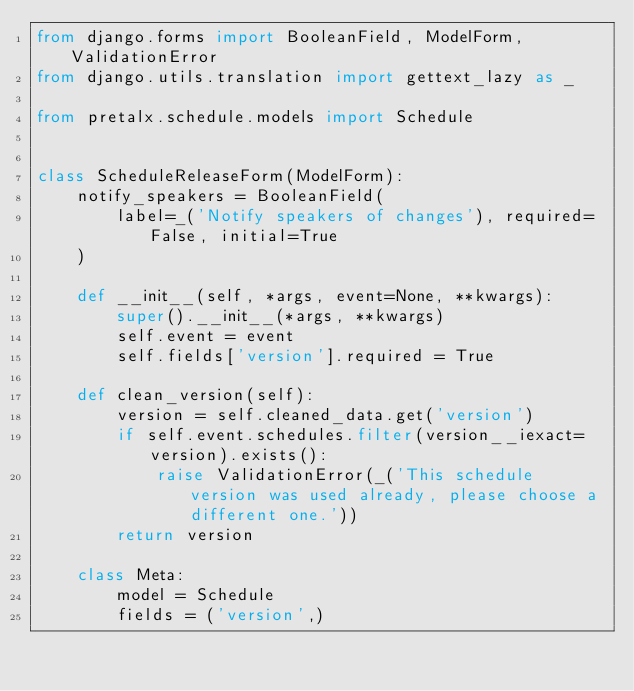<code> <loc_0><loc_0><loc_500><loc_500><_Python_>from django.forms import BooleanField, ModelForm, ValidationError
from django.utils.translation import gettext_lazy as _

from pretalx.schedule.models import Schedule


class ScheduleReleaseForm(ModelForm):
    notify_speakers = BooleanField(
        label=_('Notify speakers of changes'), required=False, initial=True
    )

    def __init__(self, *args, event=None, **kwargs):
        super().__init__(*args, **kwargs)
        self.event = event
        self.fields['version'].required = True

    def clean_version(self):
        version = self.cleaned_data.get('version')
        if self.event.schedules.filter(version__iexact=version).exists():
            raise ValidationError(_('This schedule version was used already, please choose a different one.'))
        return version

    class Meta:
        model = Schedule
        fields = ('version',)
</code> 